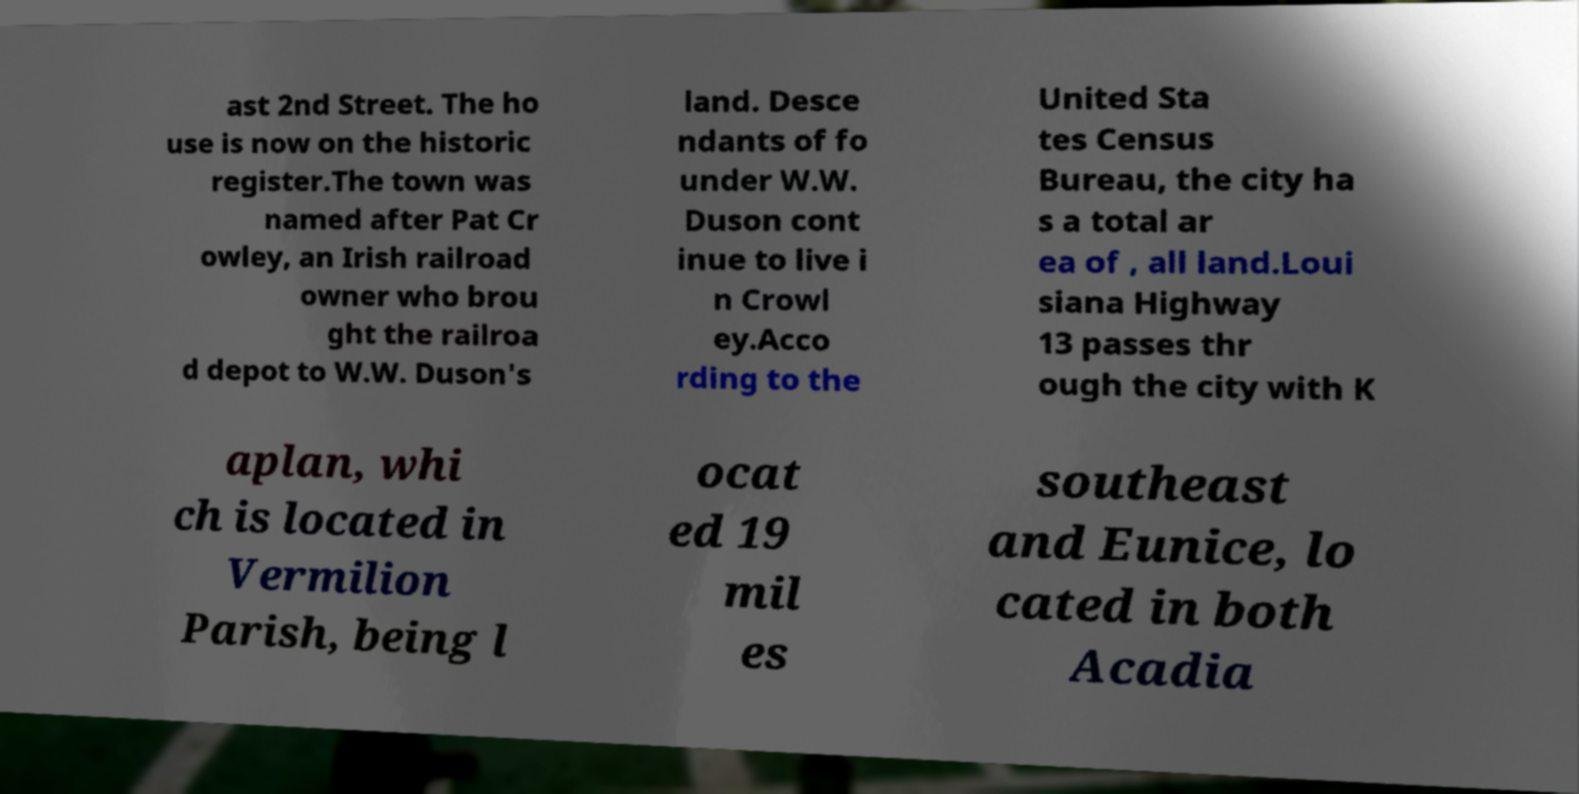For documentation purposes, I need the text within this image transcribed. Could you provide that? ast 2nd Street. The ho use is now on the historic register.The town was named after Pat Cr owley, an Irish railroad owner who brou ght the railroa d depot to W.W. Duson's land. Desce ndants of fo under W.W. Duson cont inue to live i n Crowl ey.Acco rding to the United Sta tes Census Bureau, the city ha s a total ar ea of , all land.Loui siana Highway 13 passes thr ough the city with K aplan, whi ch is located in Vermilion Parish, being l ocat ed 19 mil es southeast and Eunice, lo cated in both Acadia 